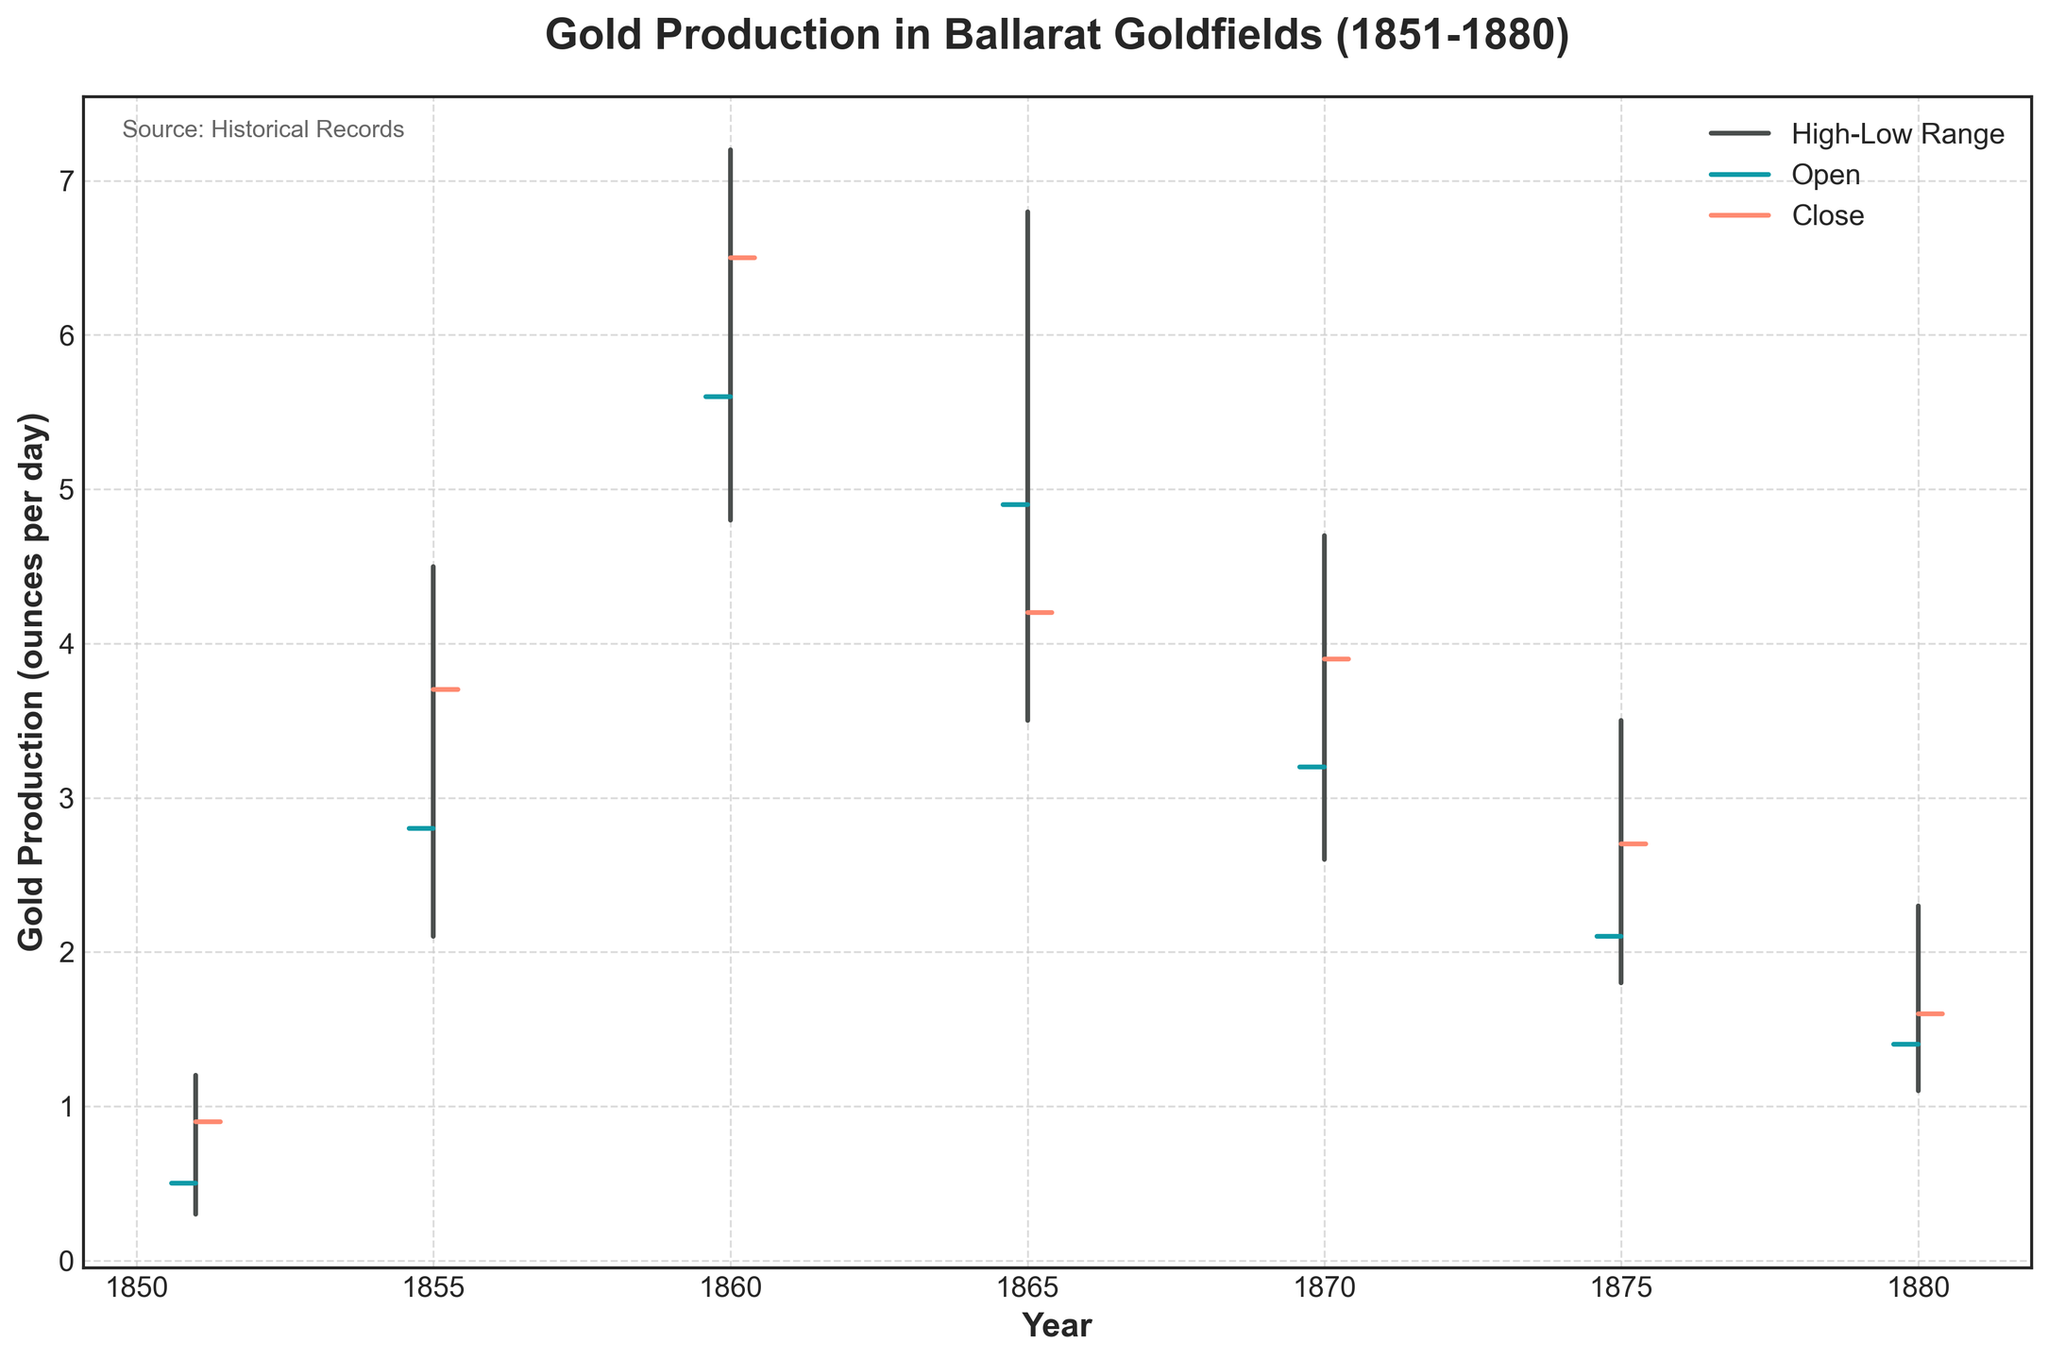What is the title of the figure? The title of the figure is located at the top and provides a summary of what the figure is about. The title here is "Gold Production in Ballarat Goldfields (1851-1880)".
Answer: Gold Production in Ballarat Goldfields (1851-1880) What does the y-axis represent? The y-axis label is present on the left side of the graph and indicates what is being measured quantitatively. Here, it represents "Gold Production (ounces per day)".
Answer: Gold Production (ounces per day) How many data points are represented in the figure? By counting the individual vertical lines in the graph, each representing one year, we can determine the number of data points. There are seven data points corresponding to the years 1851, 1855, 1860, 1865, 1870, 1875, and 1880.
Answer: 7 In which year was the highest gold production rate recorded? The highest gold production rate can be identified by the highest "High" value on the vertical line. According to the figure, it was recorded in the year 1860 with a value of 7.2 ounces per day.
Answer: 1860 What is the trend in the closing gold production rate from 1851 to 1880? The closing gold production rate can be analyzed by looking at the end points of the horizontal lines extending to the right of each vertical bar. The trend shows a general decrease from 1851 (with 0.9 ounces per day) to 1880 (with 1.6 ounces per day), with variations in between.
Answer: Decreasing trend Which year had the lowest opening gold production rate? The lowest opening value can be identified by the bottom-most starting point of the horizontal lines extending to the left of each vertical bar. The year with the lowest opening rate is 1851, with an opening rate of 0.5 ounces per day.
Answer: 1851 What is the range of gold production rates in 1865? The range of gold production rates is calculated by subtracting the lowest value from the highest value in the given year. For 1865, the range is 6.8 - 3.5 = 3.3 ounces per day.
Answer: 3.3 ounces per day How did the gold production rate change between 1855 and 1860? To determine the change, compare the closing rates of 1855 and 1860. The closing rate in 1855 was 3.7 ounces per day, and in 1860 it was 6.5 ounces per day. The change is 6.5 - 3.7 = 2.8 ounces per day, indicating an increase.
Answer: Increased by 2.8 ounces per day What is the median closing rate for the given years? To find the median closing rate, list the closing rates in ascending order and find the middle value. The closing rates are: 0.9, 1.6, 2.7, 3.7, 3.9, 4.2, 6.5. The median value, being the center value in this sorted list, is 3.9 ounces per day.
Answer: 3.9 ounces per day In which year did the gold production rate experience the highest volatility? Volatility can be inferred by the length of the vertical bars, which represent the range between the high and low values. The longest vertical bar appears in 1860, indicating the highest volatility, as it has the largest range from 4.8 to 7.2 ounces per day.
Answer: 1860 